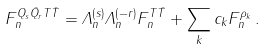<formula> <loc_0><loc_0><loc_500><loc_500>F _ { n } ^ { Q _ { s } \bar { Q } _ { r } T \bar { T } } = \Lambda _ { n } ^ { \left ( s \right ) } \Lambda _ { n } ^ { \left ( - r \right ) } F _ { n } ^ { T \bar { T } } + \sum _ { k } c _ { k } F _ { n } ^ { \rho _ { k } } \, .</formula> 